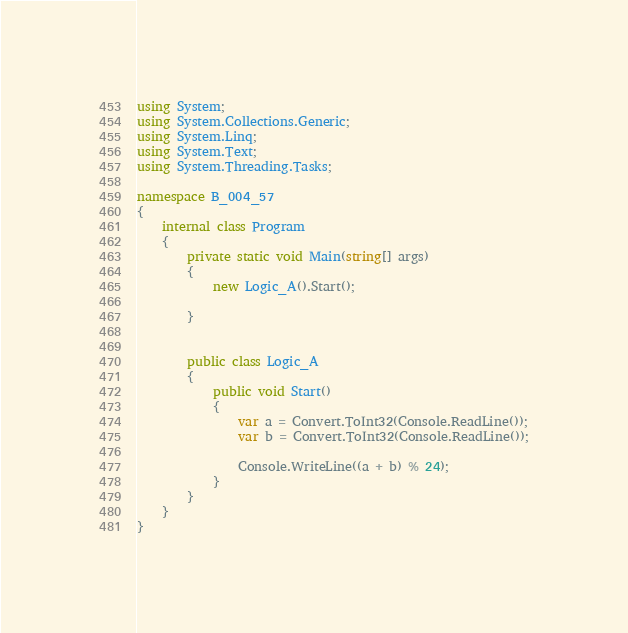<code> <loc_0><loc_0><loc_500><loc_500><_C#_>using System;
using System.Collections.Generic;
using System.Linq;
using System.Text;
using System.Threading.Tasks;

namespace B_004_57
{
    internal class Program
    {
        private static void Main(string[] args)
        {
            new Logic_A().Start();

        }


        public class Logic_A
        {
            public void Start()
            {
                var a = Convert.ToInt32(Console.ReadLine());
                var b = Convert.ToInt32(Console.ReadLine());

                Console.WriteLine((a + b) % 24);
            }
        }
    }
}</code> 